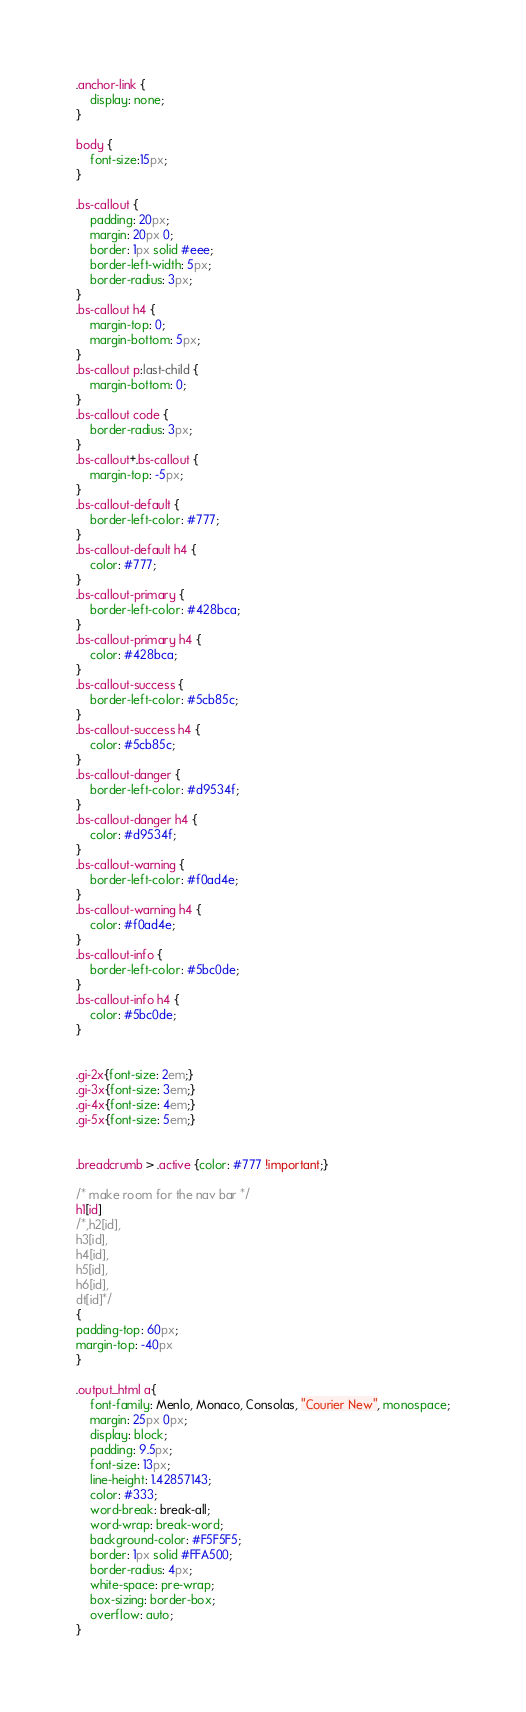<code> <loc_0><loc_0><loc_500><loc_500><_CSS_>.anchor-link {
    display: none;
}

body {
    font-size:15px;
}

.bs-callout {
    padding: 20px;
    margin: 20px 0;
    border: 1px solid #eee;
    border-left-width: 5px;
    border-radius: 3px;
}
.bs-callout h4 {
    margin-top: 0;
    margin-bottom: 5px;
}
.bs-callout p:last-child {
    margin-bottom: 0;
}
.bs-callout code {
    border-radius: 3px;
}
.bs-callout+.bs-callout {
    margin-top: -5px;
}
.bs-callout-default {
    border-left-color: #777;
}
.bs-callout-default h4 {
    color: #777;
}
.bs-callout-primary {
    border-left-color: #428bca;
}
.bs-callout-primary h4 {
    color: #428bca;
}
.bs-callout-success {
    border-left-color: #5cb85c;
}
.bs-callout-success h4 {
    color: #5cb85c;
}
.bs-callout-danger {
    border-left-color: #d9534f;
}
.bs-callout-danger h4 {
    color: #d9534f;
}
.bs-callout-warning {
    border-left-color: #f0ad4e;
}
.bs-callout-warning h4 {
    color: #f0ad4e;
}
.bs-callout-info {
    border-left-color: #5bc0de;
}
.bs-callout-info h4 {
    color: #5bc0de;
}


.gi-2x{font-size: 2em;}
.gi-3x{font-size: 3em;}
.gi-4x{font-size: 4em;}
.gi-5x{font-size: 5em;}


.breadcrumb > .active {color: #777 !important;}

/* make room for the nav bar */
h1[id]
/*,h2[id],
h3[id],
h4[id],
h5[id],
h6[id],
dt[id]*/
{
padding-top: 60px;
margin-top: -40px
}

.output_html a{
    font-family: Menlo, Monaco, Consolas, "Courier New", monospace;
    margin: 25px 0px;
    display: block;
    padding: 9.5px;
    font-size: 13px;
    line-height: 1.42857143;
    color: #333;
    word-break: break-all;
    word-wrap: break-word;
    background-color: #F5F5F5;
    border: 1px solid #FFA500;
    border-radius: 4px;
    white-space: pre-wrap;
    box-sizing: border-box;
    overflow: auto;
}
</code> 